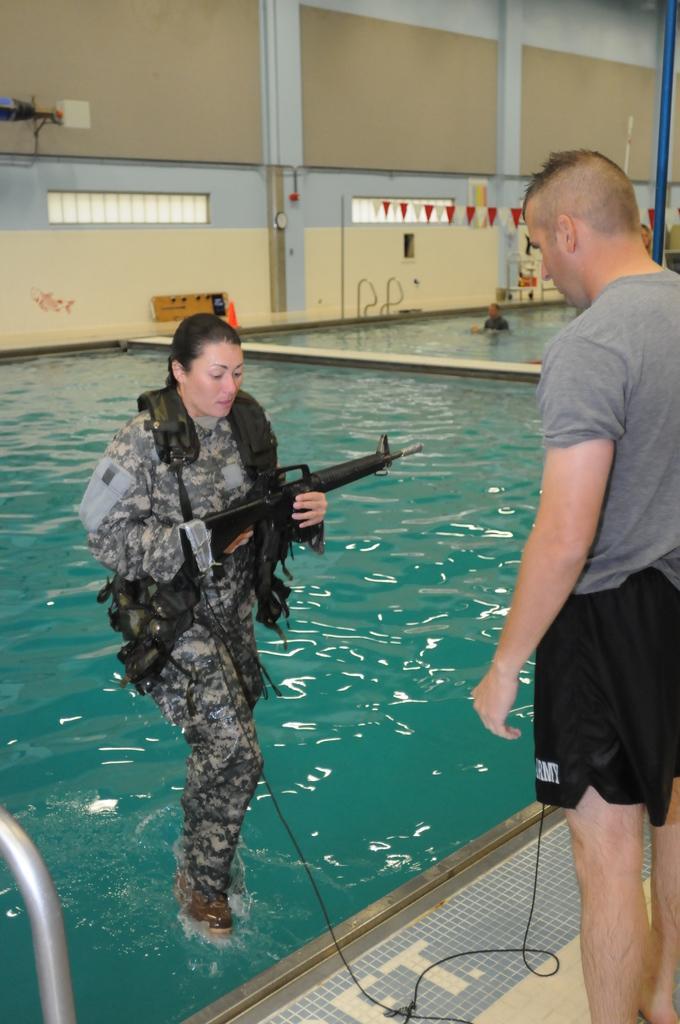In one or two sentences, can you explain what this image depicts? in this image we can see a swimming pool. On the surface of water, one lady is present. She is holding gun in her hand and wearing army uniform. Right side of the image we can see a man is standing, he is wearing a grey t-shirt with black shorts. Background of the image wall is present. 